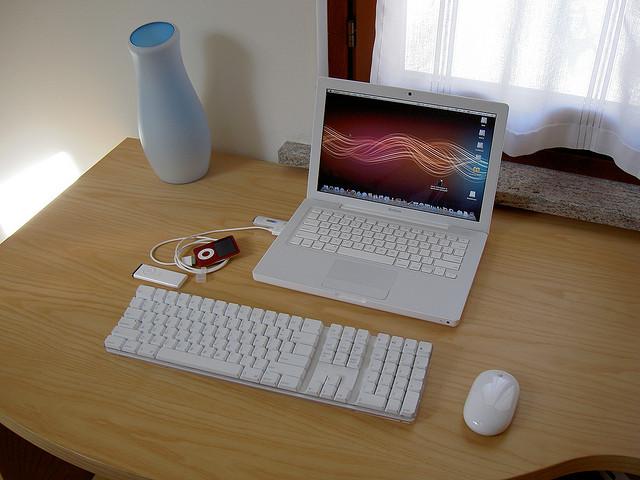Is the computer a laptop or a desktop?
Concise answer only. Laptop. How many items are in front of the keyboard?
Keep it brief. 0. Is the keyboard wireless?
Concise answer only. Yes. What color is the keyboard?
Concise answer only. White. Is there flowers in the vase?
Write a very short answer. No. Is the mouse wireless?
Write a very short answer. Yes. What color is the mouse?
Concise answer only. White. Is this a new Mac?
Concise answer only. No. What color is the vase?
Write a very short answer. Blue. What communication device is on the nightstand?
Keep it brief. Computer. How many computer monitors are there?
Give a very brief answer. 1. What is on the table?
Quick response, please. Laptop. 